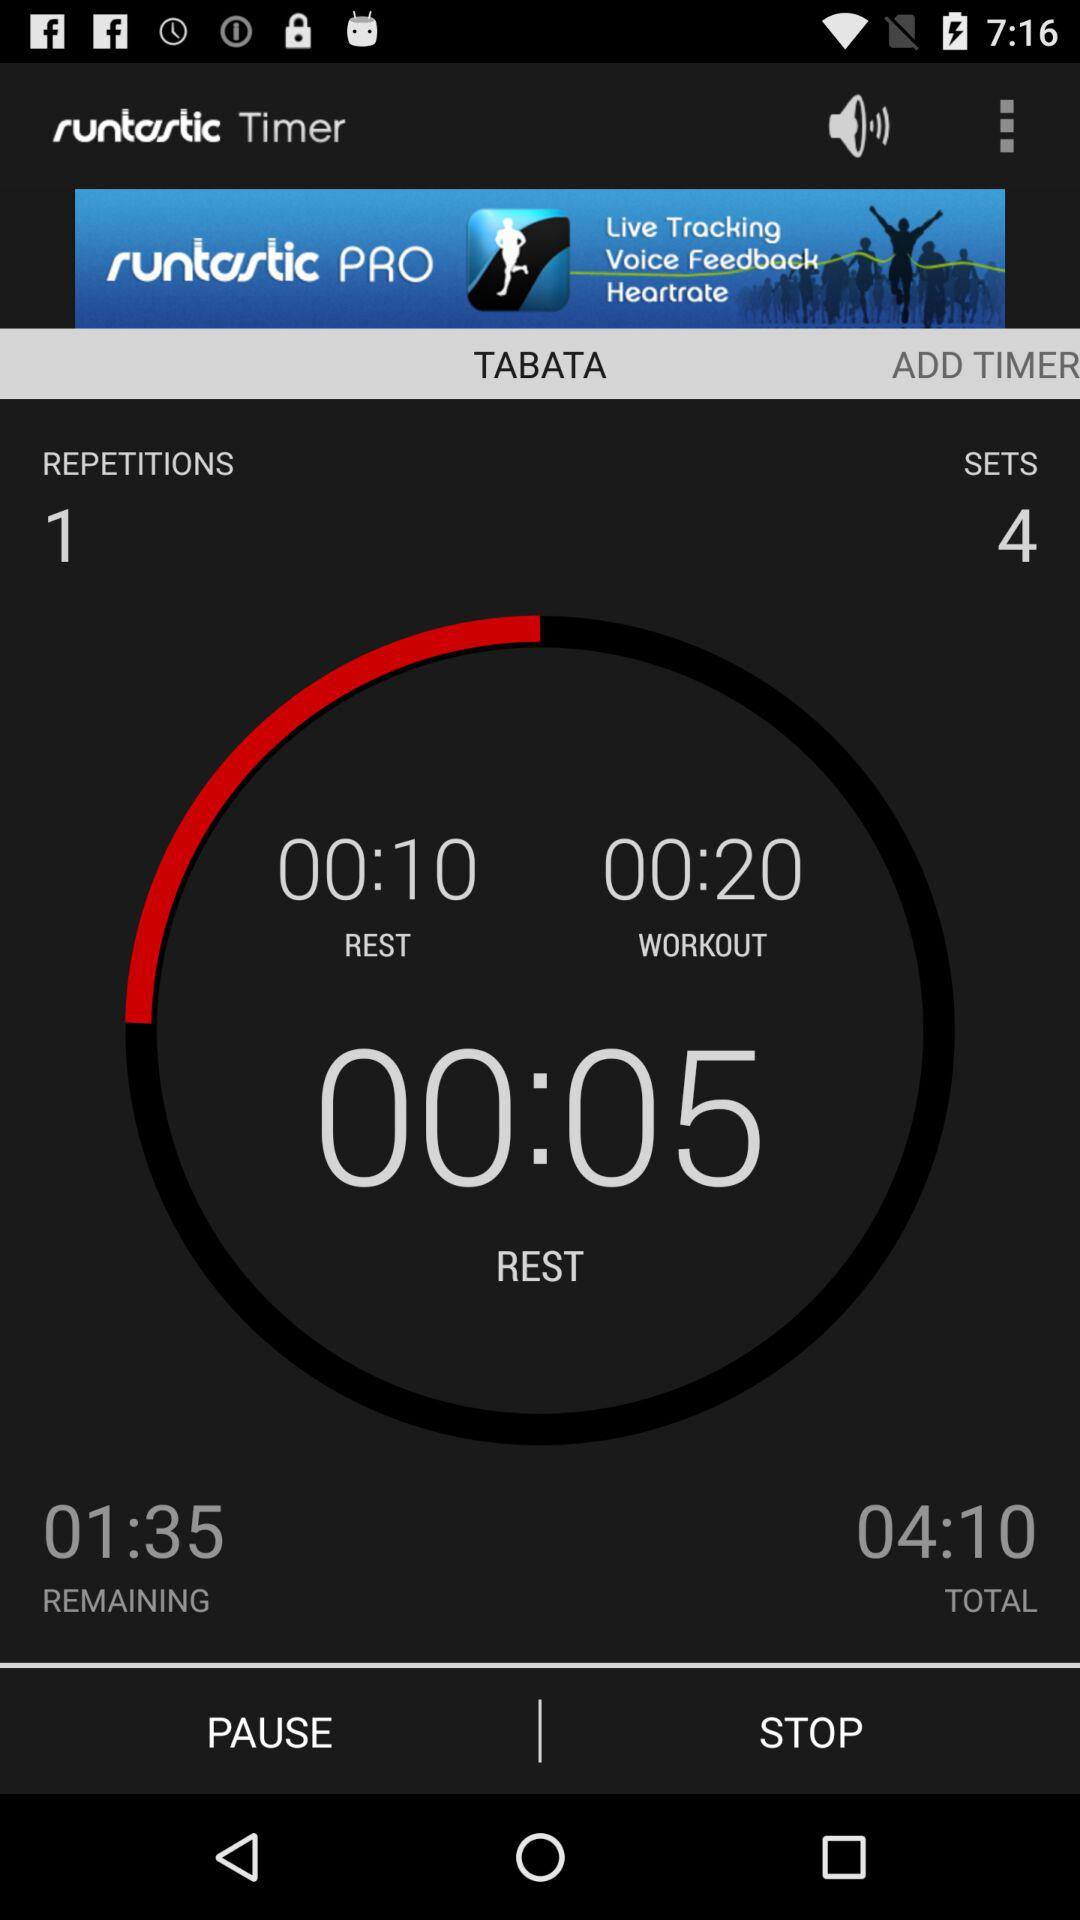What is the remaining time? The remaining time is 1 minute and 35 seconds. 